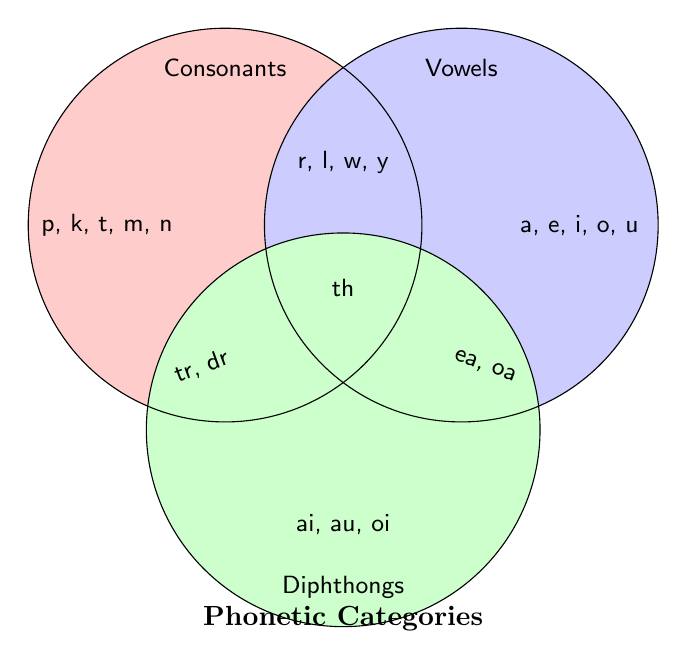What is the title of the Venn Diagram? The title is located at the bottom of the figure. By reading it, we can determine the title.
Answer: Phonetic Categories Which category contains the elements "p, k, t, m, n"? The elements "p, k, t, m, n" are located inside the circle labeled "Consonants" on the left side of the Venn Diagram.
Answer: Consonants What elements are common to Consonants and Diphthongs? Find the overlapping area between the Consonants and Diphthongs circles and identify the elements in that section.
Answer: tr, dr How many elements are there in the Vowels category? Count the number of elements listed inside the Vowels circle on the right side of the Venn Diagram.
Answer: 5 Which elements belong to all three categories? Identify the elements in the center where all three circles converge. There is only one element listed in this central region.
Answer: th Can you list the elements found in both Consonants and Vowels but not in Diphthongs? Identify the elements in the overlapping area between the Consonants and Vowels circles while excluding elements in the Diphthongs circle.
Answer: r, l, w, y Which category has fewer elements: Consonants or Diphthongs? Compare the number of elements in the Consonants and Diphthongs circles. Consonants have 5 elements while Diphthongs have 3.
Answer: Diphthongs Name an element that is unique to the Vowels category. Look inside the Vowels circle and identify elements that do not overlap with other categories.
Answer: a What are the elements in the intersection of Vowels and Diphthongs? Look for the area where Vowels and Diphthongs circles overlap to find the common elements.
Answer: ea, oa 